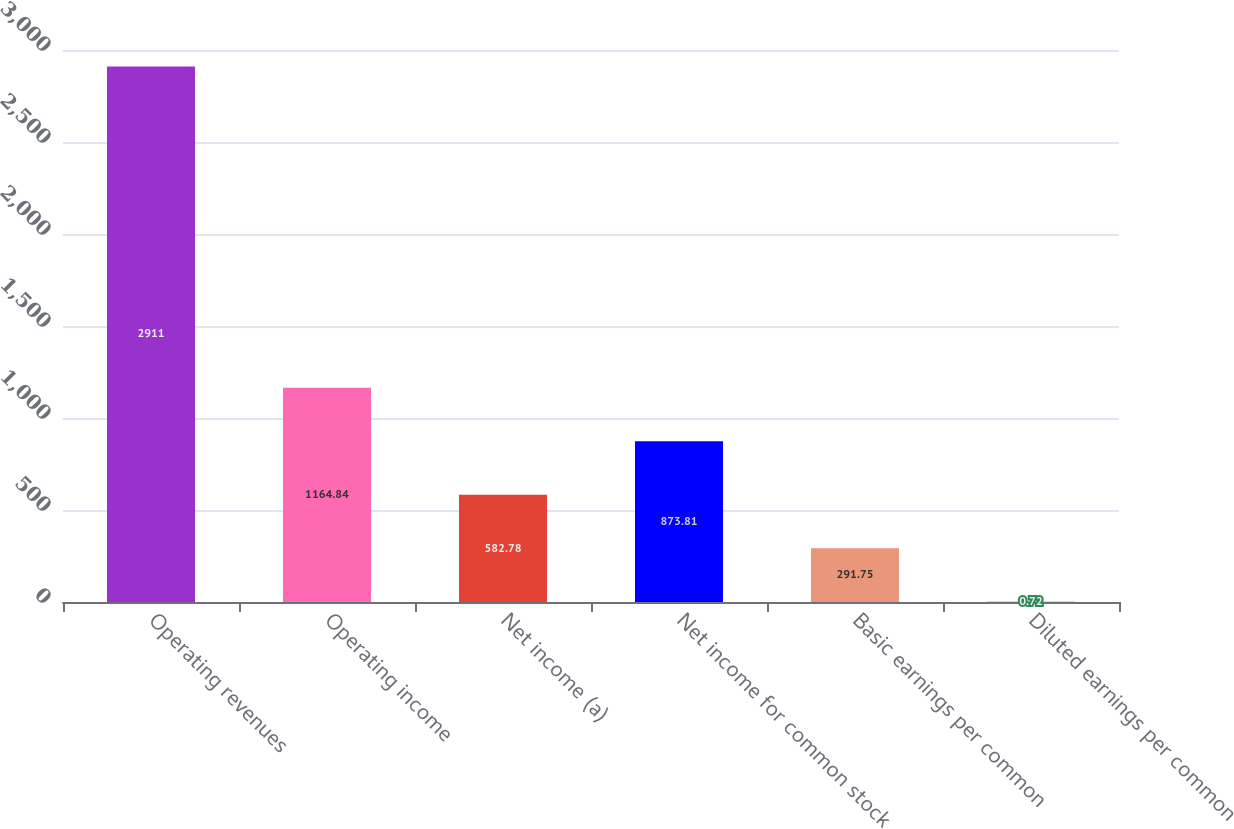<chart> <loc_0><loc_0><loc_500><loc_500><bar_chart><fcel>Operating revenues<fcel>Operating income<fcel>Net income (a)<fcel>Net income for common stock<fcel>Basic earnings per common<fcel>Diluted earnings per common<nl><fcel>2911<fcel>1164.84<fcel>582.78<fcel>873.81<fcel>291.75<fcel>0.72<nl></chart> 